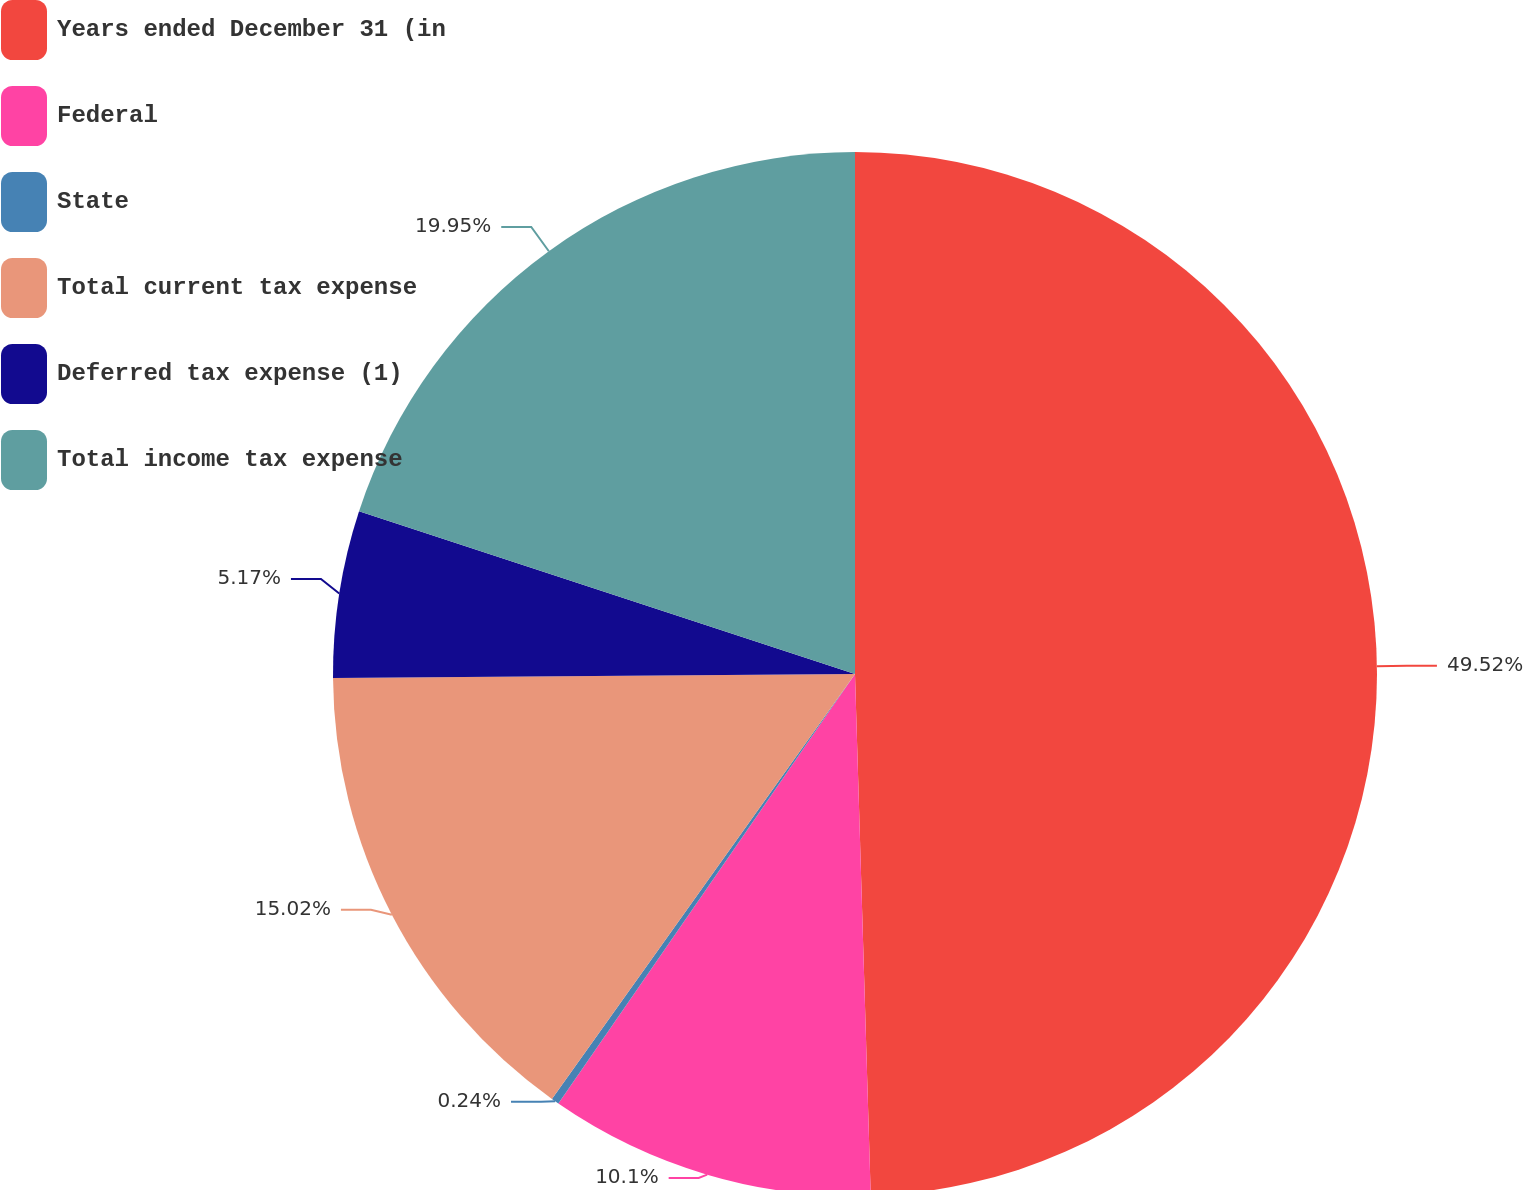Convert chart. <chart><loc_0><loc_0><loc_500><loc_500><pie_chart><fcel>Years ended December 31 (in<fcel>Federal<fcel>State<fcel>Total current tax expense<fcel>Deferred tax expense (1)<fcel>Total income tax expense<nl><fcel>49.52%<fcel>10.1%<fcel>0.24%<fcel>15.02%<fcel>5.17%<fcel>19.95%<nl></chart> 